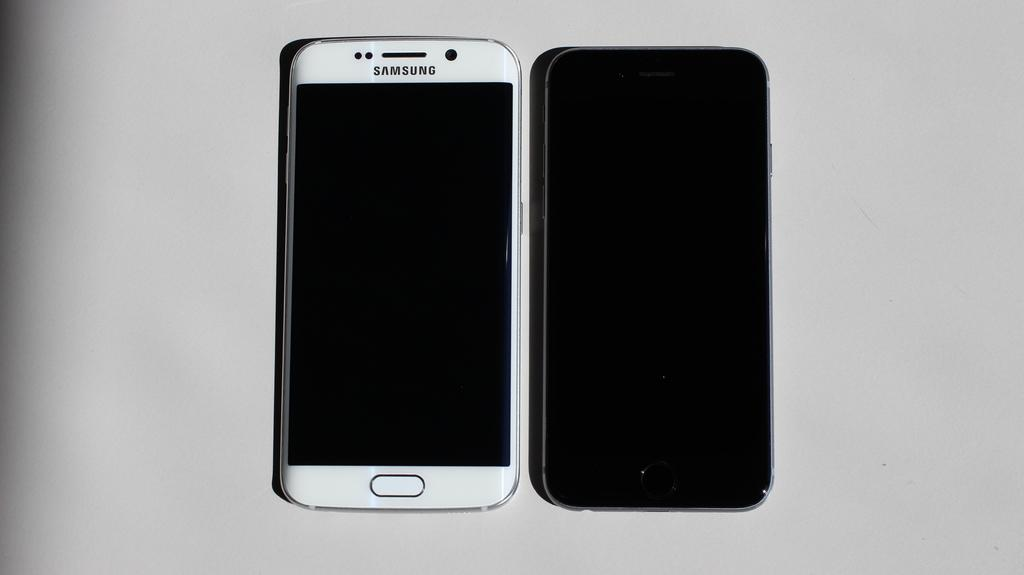Provide a one-sentence caption for the provided image. Two phone, one of them white and a samsung. 